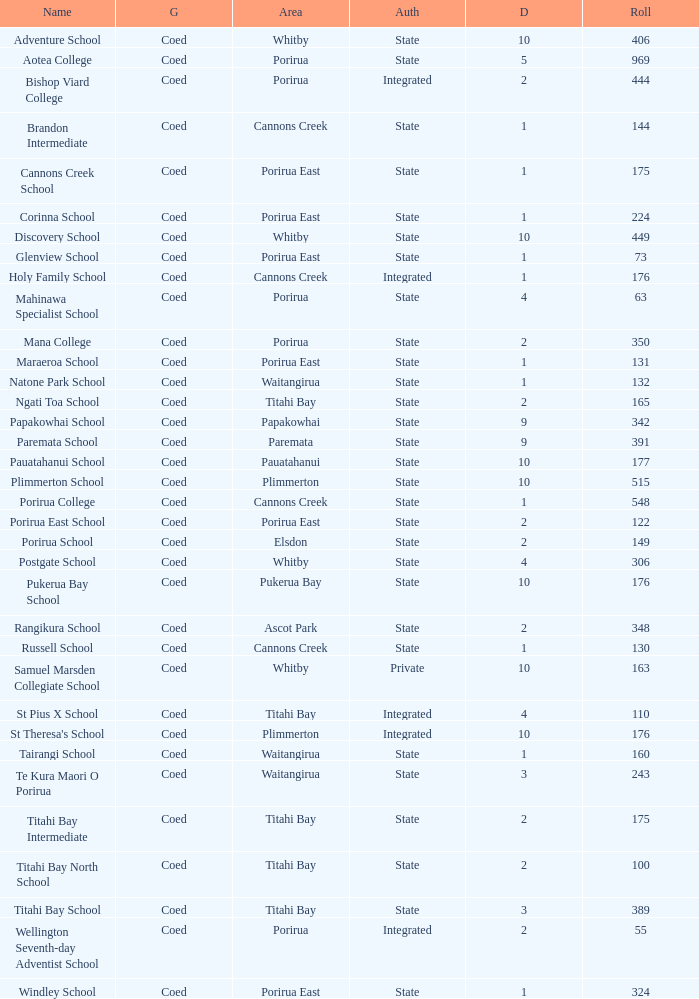What is the roll of Bishop Viard College (An Integrated College), which has a decile larger than 1? 1.0. 